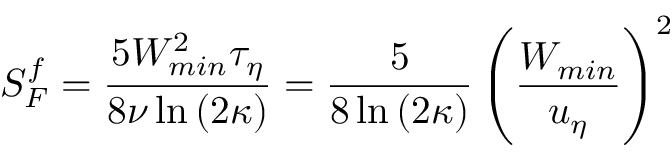<formula> <loc_0><loc_0><loc_500><loc_500>S _ { F } ^ { f } = \frac { 5 W _ { \min } ^ { 2 } \tau _ { \eta } } { 8 \nu \ln { ( 2 \kappa ) } } = \frac { 5 } { 8 \ln { ( 2 \kappa ) } } \left ( \frac { W _ { \min } } { u _ { \eta } } \right ) ^ { 2 }</formula> 